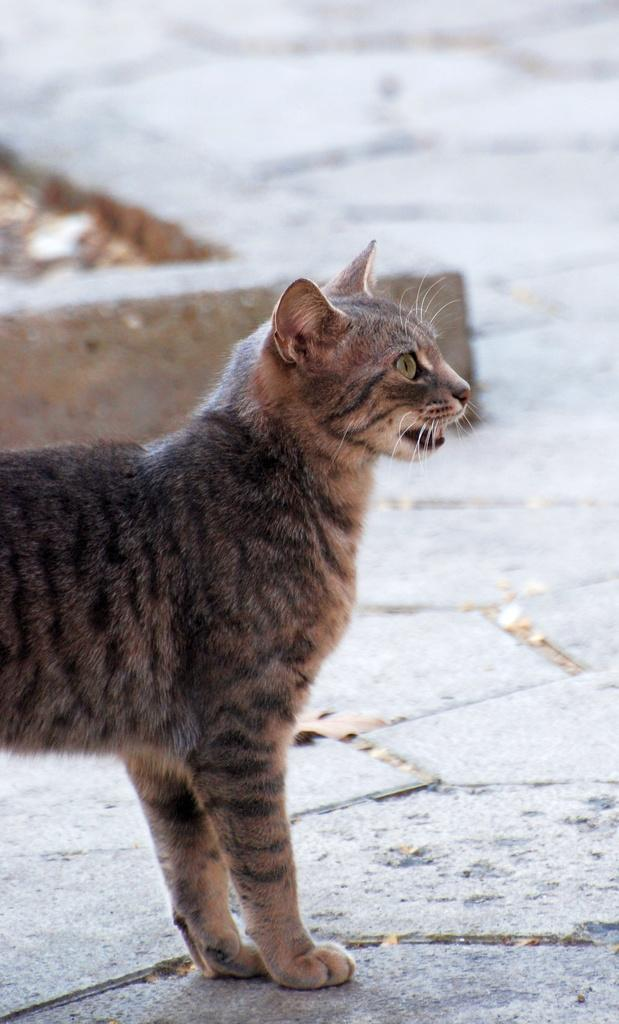What type of animal is in the picture? There is a cat in the picture. Can you describe the color pattern of the cat? The cat has a color pattern of white, black, and grey. What type of discussion is taking place in the picture? There is no discussion present in the image; it features a cat with a white, black, and grey color pattern. Can you see a car in the picture? There is no car present in the image; it features a cat with a white, black, and grey color pattern. 